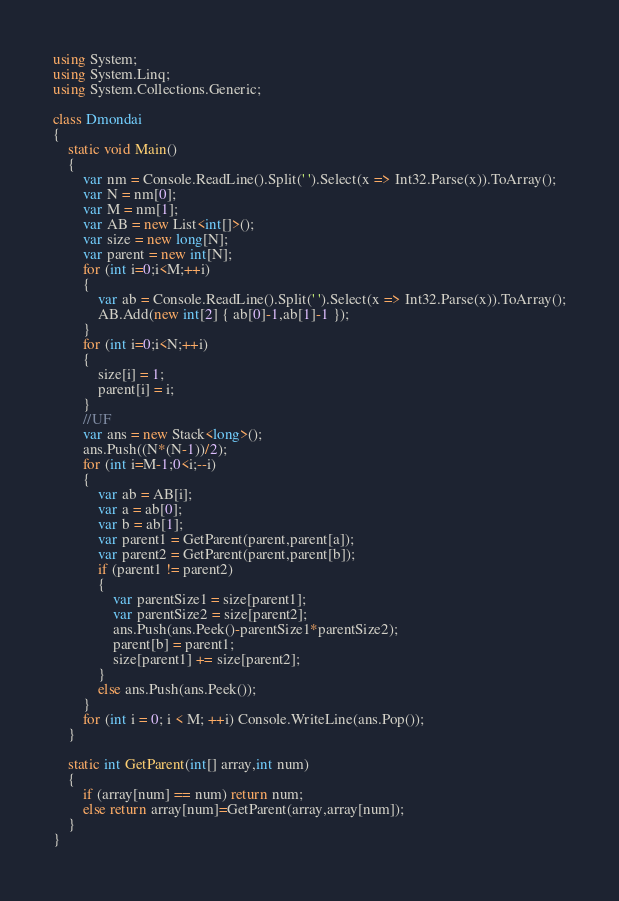<code> <loc_0><loc_0><loc_500><loc_500><_C#_>using System;
using System.Linq;
using System.Collections.Generic;

class Dmondai
{
    static void Main()
    {
        var nm = Console.ReadLine().Split(' ').Select(x => Int32.Parse(x)).ToArray();
        var N = nm[0];
        var M = nm[1];
        var AB = new List<int[]>();
        var size = new long[N];
        var parent = new int[N];
        for (int i=0;i<M;++i)
        {
            var ab = Console.ReadLine().Split(' ').Select(x => Int32.Parse(x)).ToArray();
            AB.Add(new int[2] { ab[0]-1,ab[1]-1 });
        }
        for (int i=0;i<N;++i)
        {
            size[i] = 1;
            parent[i] = i;
        }
        //UF
        var ans = new Stack<long>();
        ans.Push((N*(N-1))/2);
        for (int i=M-1;0<i;--i)
        {
            var ab = AB[i];
            var a = ab[0];
            var b = ab[1];
            var parent1 = GetParent(parent,parent[a]);
            var parent2 = GetParent(parent,parent[b]);
            if (parent1 != parent2)
            {
                var parentSize1 = size[parent1];
                var parentSize2 = size[parent2];
                ans.Push(ans.Peek()-parentSize1*parentSize2);
                parent[b] = parent1;
                size[parent1] += size[parent2];
            }
            else ans.Push(ans.Peek());
        }
        for (int i = 0; i < M; ++i) Console.WriteLine(ans.Pop());
    }

    static int GetParent(int[] array,int num)
    {
        if (array[num] == num) return num;
        else return array[num]=GetParent(array,array[num]);
    }
}</code> 